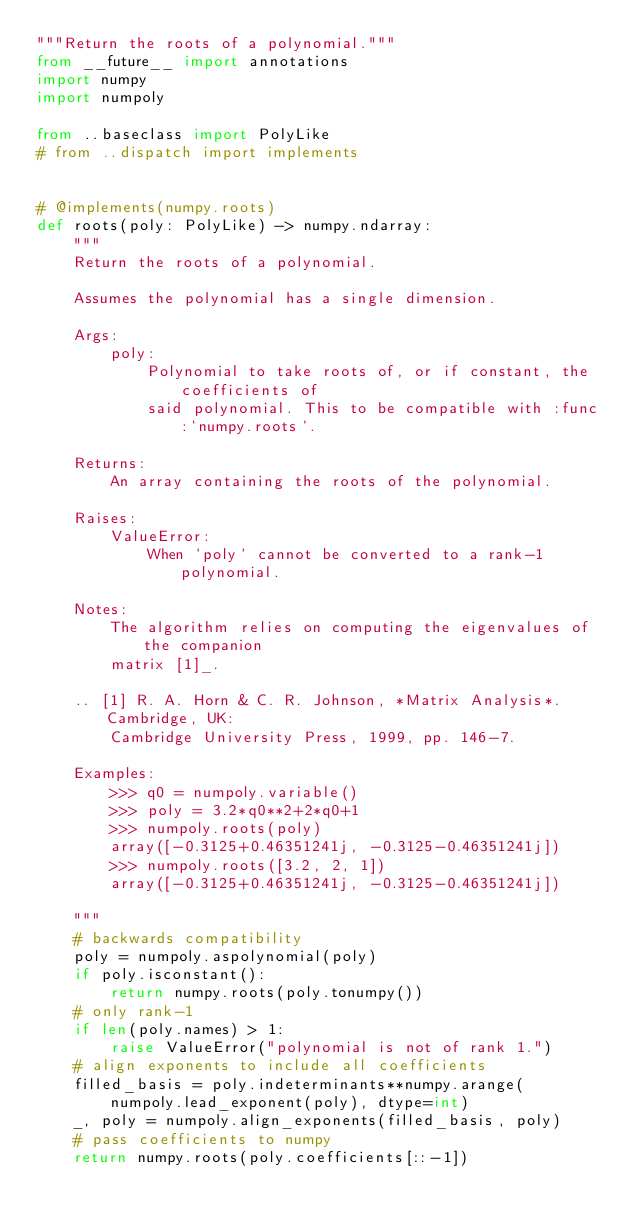<code> <loc_0><loc_0><loc_500><loc_500><_Python_>"""Return the roots of a polynomial."""
from __future__ import annotations
import numpy
import numpoly

from ..baseclass import PolyLike
# from ..dispatch import implements


# @implements(numpy.roots)
def roots(poly: PolyLike) -> numpy.ndarray:
    """
    Return the roots of a polynomial.

    Assumes the polynomial has a single dimension.

    Args:
        poly:
            Polynomial to take roots of, or if constant, the coefficients of
            said polynomial. This to be compatible with :func:`numpy.roots`.

    Returns:
        An array containing the roots of the polynomial.

    Raises:
        ValueError:
            When `poly` cannot be converted to a rank-1 polynomial.

    Notes:
        The algorithm relies on computing the eigenvalues of the companion
        matrix [1]_.

    .. [1] R. A. Horn & C. R. Johnson, *Matrix Analysis*.  Cambridge, UK:
        Cambridge University Press, 1999, pp. 146-7.

    Examples:
        >>> q0 = numpoly.variable()
        >>> poly = 3.2*q0**2+2*q0+1
        >>> numpoly.roots(poly)
        array([-0.3125+0.46351241j, -0.3125-0.46351241j])
        >>> numpoly.roots([3.2, 2, 1])
        array([-0.3125+0.46351241j, -0.3125-0.46351241j])

    """
    # backwards compatibility
    poly = numpoly.aspolynomial(poly)
    if poly.isconstant():
        return numpy.roots(poly.tonumpy())
    # only rank-1
    if len(poly.names) > 1:
        raise ValueError("polynomial is not of rank 1.")
    # align exponents to include all coefficients
    filled_basis = poly.indeterminants**numpy.arange(
        numpoly.lead_exponent(poly), dtype=int)
    _, poly = numpoly.align_exponents(filled_basis, poly)
    # pass coefficients to numpy
    return numpy.roots(poly.coefficients[::-1])
</code> 